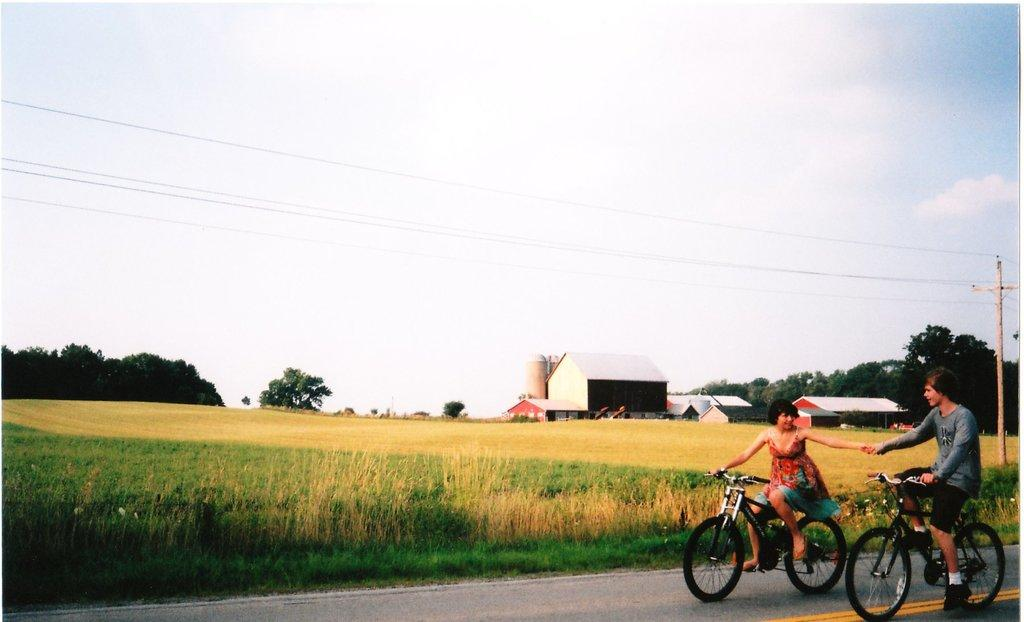How many people are in the image? There are two people in the image, a woman and a man. What are the woman and the man doing in the image? Both the woman and the man are riding a bicycle in the image. What can be seen in the background of the image? In the background of the image, there is a farm, a building, trees, an electric pole, and the sky. What type of bell can be heard ringing in the image? There is no bell present in the image, and therefore no sound can be heard. What type of mist is visible in the image? There is no mist visible in the image; the sky is visible in the background. 